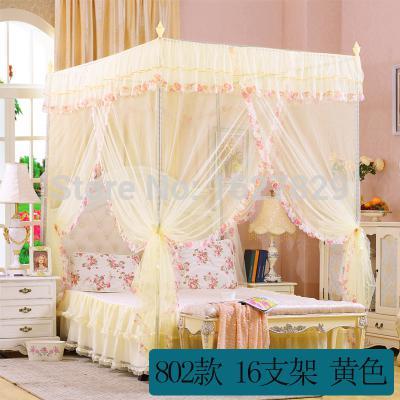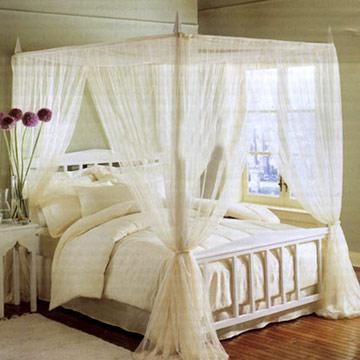The first image is the image on the left, the second image is the image on the right. Analyze the images presented: Is the assertion "A bed has an aqua colored canopy that is gathered at the four posts." valid? Answer yes or no. No. The first image is the image on the left, the second image is the image on the right. Considering the images on both sides, is "Green bed drapes are tied on to bed poles." valid? Answer yes or no. No. 